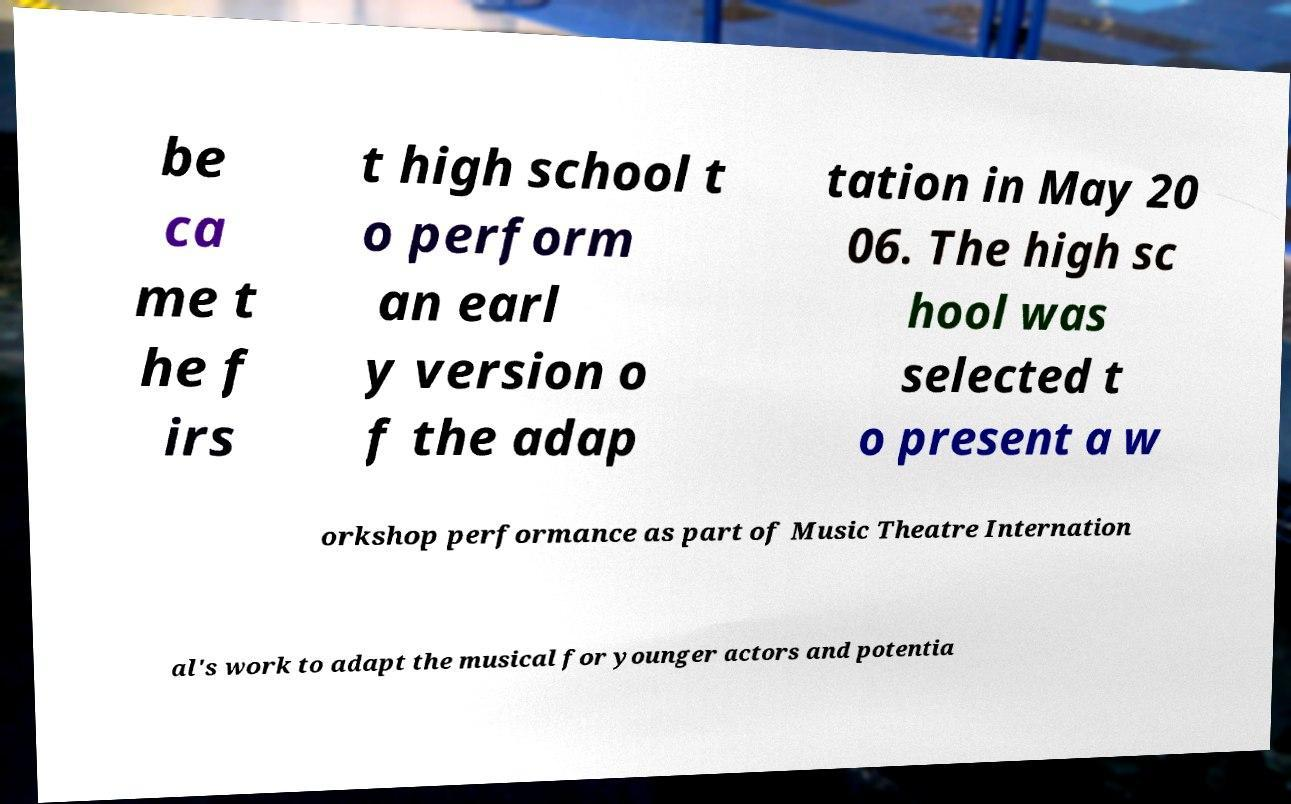What messages or text are displayed in this image? I need them in a readable, typed format. be ca me t he f irs t high school t o perform an earl y version o f the adap tation in May 20 06. The high sc hool was selected t o present a w orkshop performance as part of Music Theatre Internation al's work to adapt the musical for younger actors and potentia 